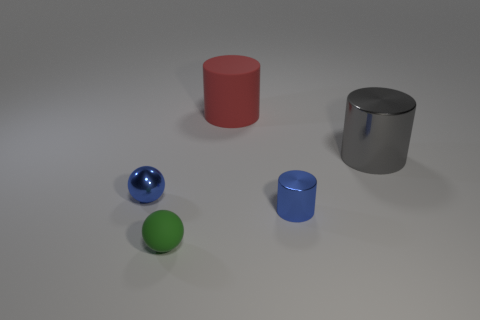What material properties are depicted in the shapes within the image? The image shows shapes with various material qualities. The blue sphere and the silver cylinder have reflective surfaces, indicating a metallic or glossy texture. The red cylinder and the green sphere have a matte finish, which scatters light and gives them a non-reflective appearance. Lastly, the blue cylinder seems to share the glossy finish of the other blue object, making it look reflective as well. 